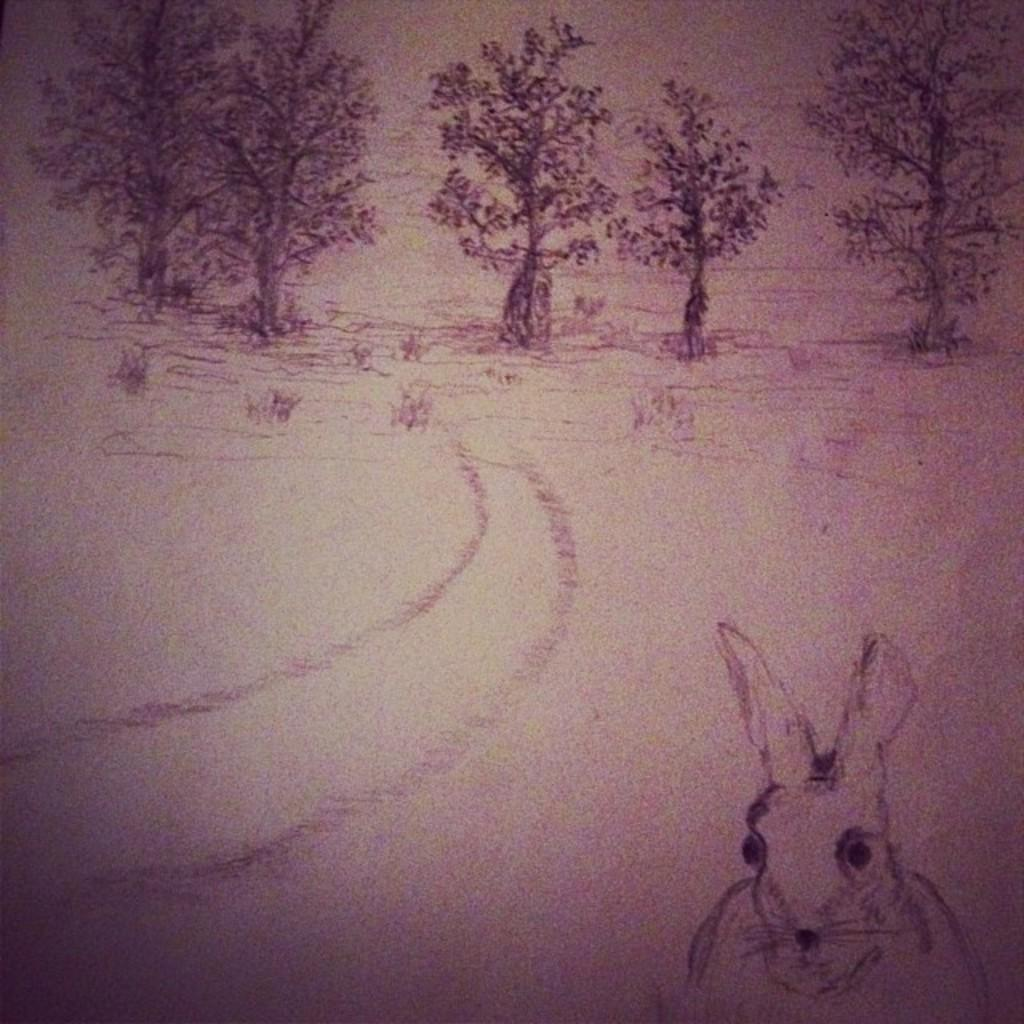What type of art is depicted in the image? The image contains an art of a tree and an art of a rabbit. Can you describe the subjects of the art in the image? The art of a tree and the art of a rabbit are the subjects depicted in the image. How many sisters are present in the image? There are no sisters present in the image; it contains an art of a tree and an art of a rabbit. What type of pest can be seen in the image? There is no pest present in the image; it contains an art of a tree and an art of a rabbit. 